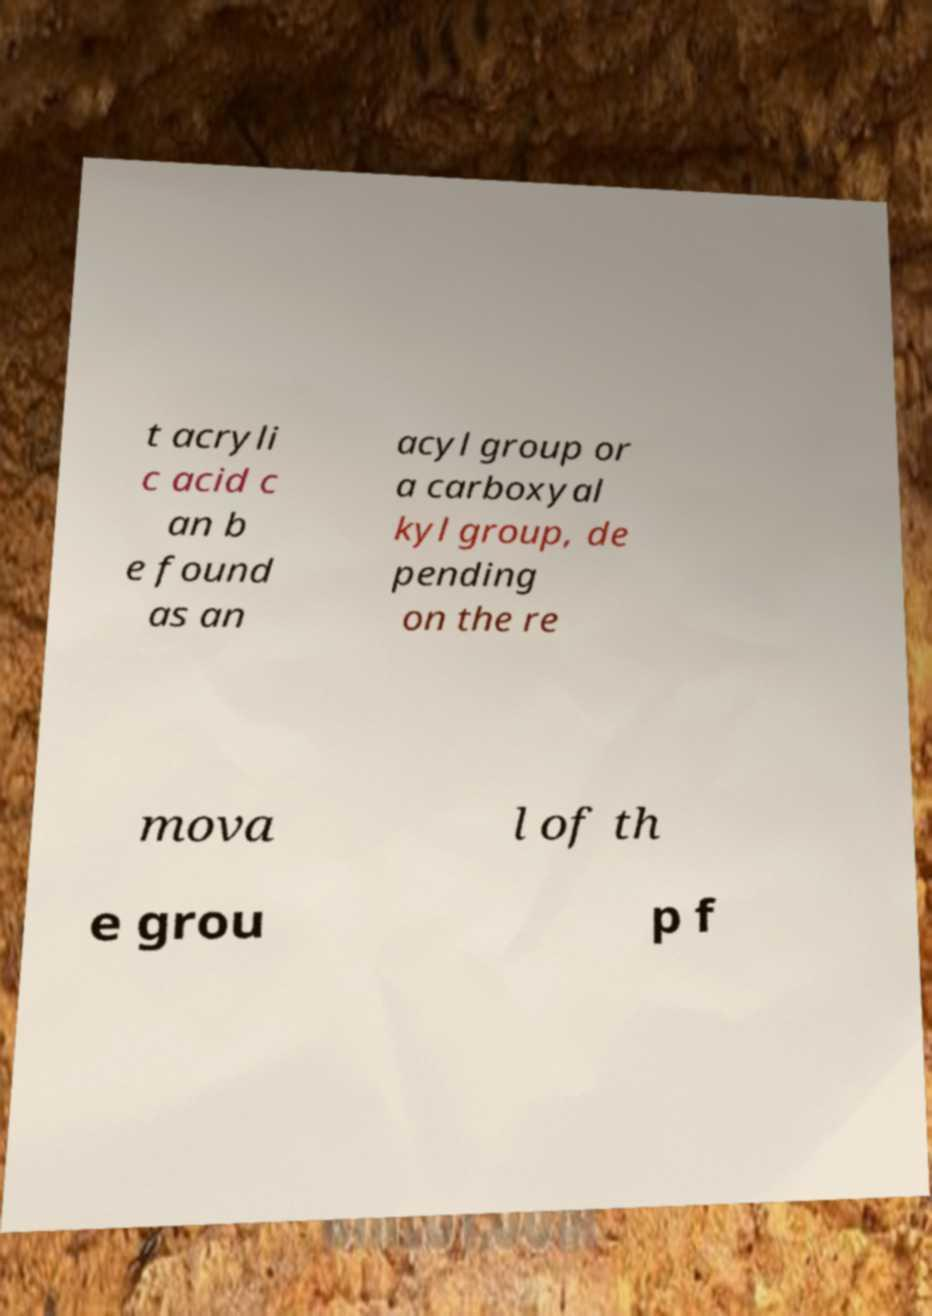I need the written content from this picture converted into text. Can you do that? t acryli c acid c an b e found as an acyl group or a carboxyal kyl group, de pending on the re mova l of th e grou p f 